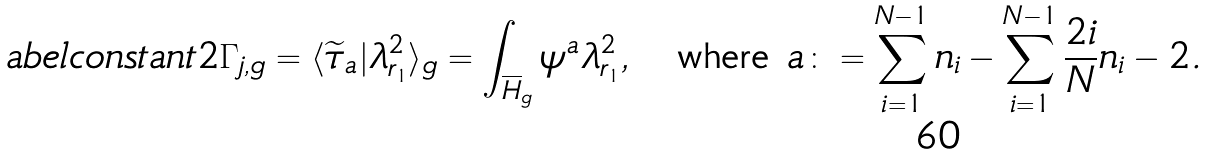<formula> <loc_0><loc_0><loc_500><loc_500>\L a b e l { c o n s t a n t 2 } \Gamma _ { j , g } = \langle \widetilde { \tau } _ { a } | \lambda ^ { 2 } _ { r _ { 1 } } \rangle _ { g } = \int _ { \overline { H } _ { g } } \psi ^ { a } \lambda ^ { 2 } _ { r _ { 1 } } , \quad \text {where } a \colon = \sum _ { i = 1 } ^ { N - 1 } n _ { i } - \sum _ { i = 1 } ^ { N - 1 } \frac { 2 i } { N } n _ { i } - 2 .</formula> 